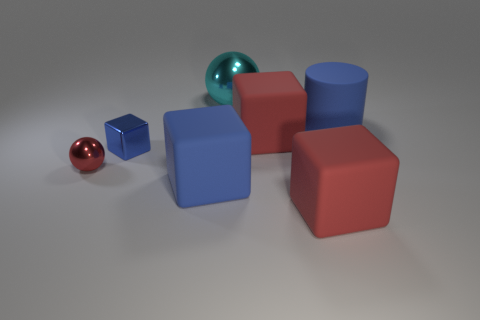Is the number of large blue blocks behind the small blue metal cube greater than the number of blue blocks behind the cyan shiny thing?
Make the answer very short. No. There is a large cyan metal object; how many blue rubber blocks are on the left side of it?
Offer a terse response. 1. Is the red ball made of the same material as the object that is behind the big rubber cylinder?
Give a very brief answer. Yes. Are there any other things that have the same shape as the cyan object?
Provide a short and direct response. Yes. Is the small sphere made of the same material as the tiny blue block?
Keep it short and to the point. Yes. There is a large blue object left of the cyan shiny ball; are there any shiny spheres to the left of it?
Your answer should be compact. Yes. What number of large rubber objects are both behind the tiny block and on the left side of the blue rubber cylinder?
Keep it short and to the point. 1. The big blue object that is in front of the big blue matte cylinder has what shape?
Offer a very short reply. Cube. How many other matte blocks have the same size as the blue rubber cube?
Keep it short and to the point. 2. There is a big object left of the big metallic thing; is it the same color as the cylinder?
Provide a succinct answer. Yes. 